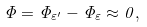Convert formula to latex. <formula><loc_0><loc_0><loc_500><loc_500>\Phi = \Phi _ { \varepsilon ^ { \prime } } - \Phi _ { \varepsilon } \approx 0 ,</formula> 